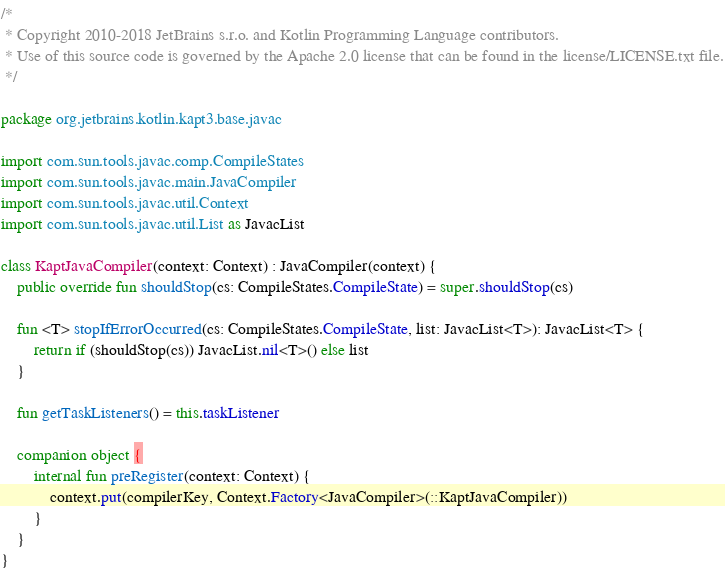<code> <loc_0><loc_0><loc_500><loc_500><_Kotlin_>/*
 * Copyright 2010-2018 JetBrains s.r.o. and Kotlin Programming Language contributors.
 * Use of this source code is governed by the Apache 2.0 license that can be found in the license/LICENSE.txt file.
 */

package org.jetbrains.kotlin.kapt3.base.javac

import com.sun.tools.javac.comp.CompileStates
import com.sun.tools.javac.main.JavaCompiler
import com.sun.tools.javac.util.Context
import com.sun.tools.javac.util.List as JavacList

class KaptJavaCompiler(context: Context) : JavaCompiler(context) {
    public override fun shouldStop(cs: CompileStates.CompileState) = super.shouldStop(cs)

    fun <T> stopIfErrorOccurred(cs: CompileStates.CompileState, list: JavacList<T>): JavacList<T> {
        return if (shouldStop(cs)) JavacList.nil<T>() else list
    }

    fun getTaskListeners() = this.taskListener

    companion object {
        internal fun preRegister(context: Context) {
            context.put(compilerKey, Context.Factory<JavaCompiler>(::KaptJavaCompiler))
        }
    }
}</code> 